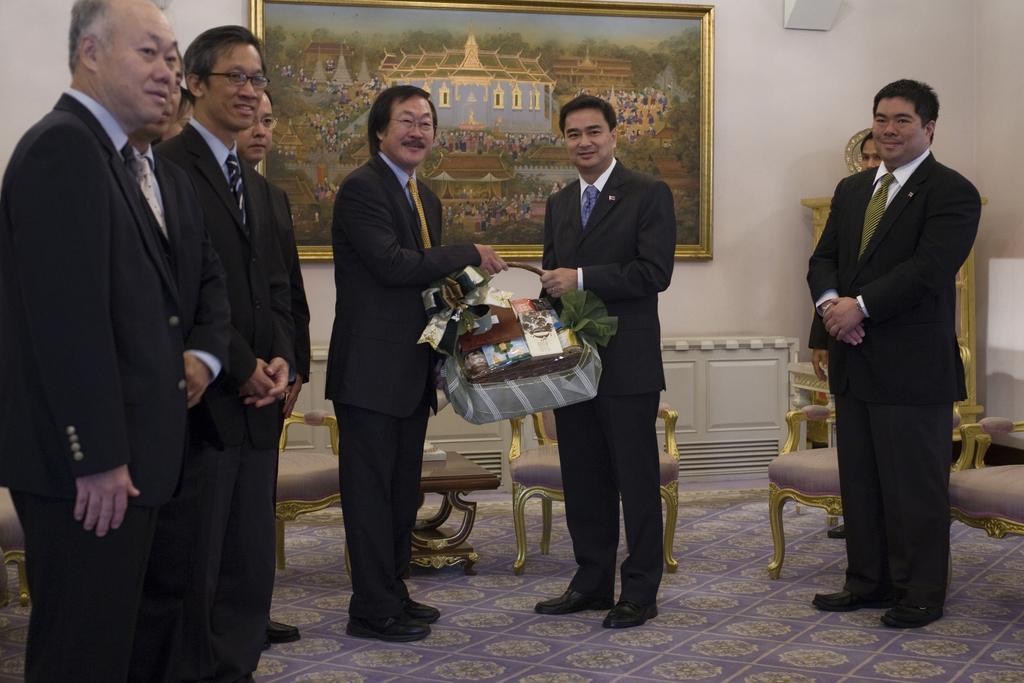In one or two sentences, can you explain what this image depicts? In this image i can see i can see a group of men are standing on the floor and smiling. 